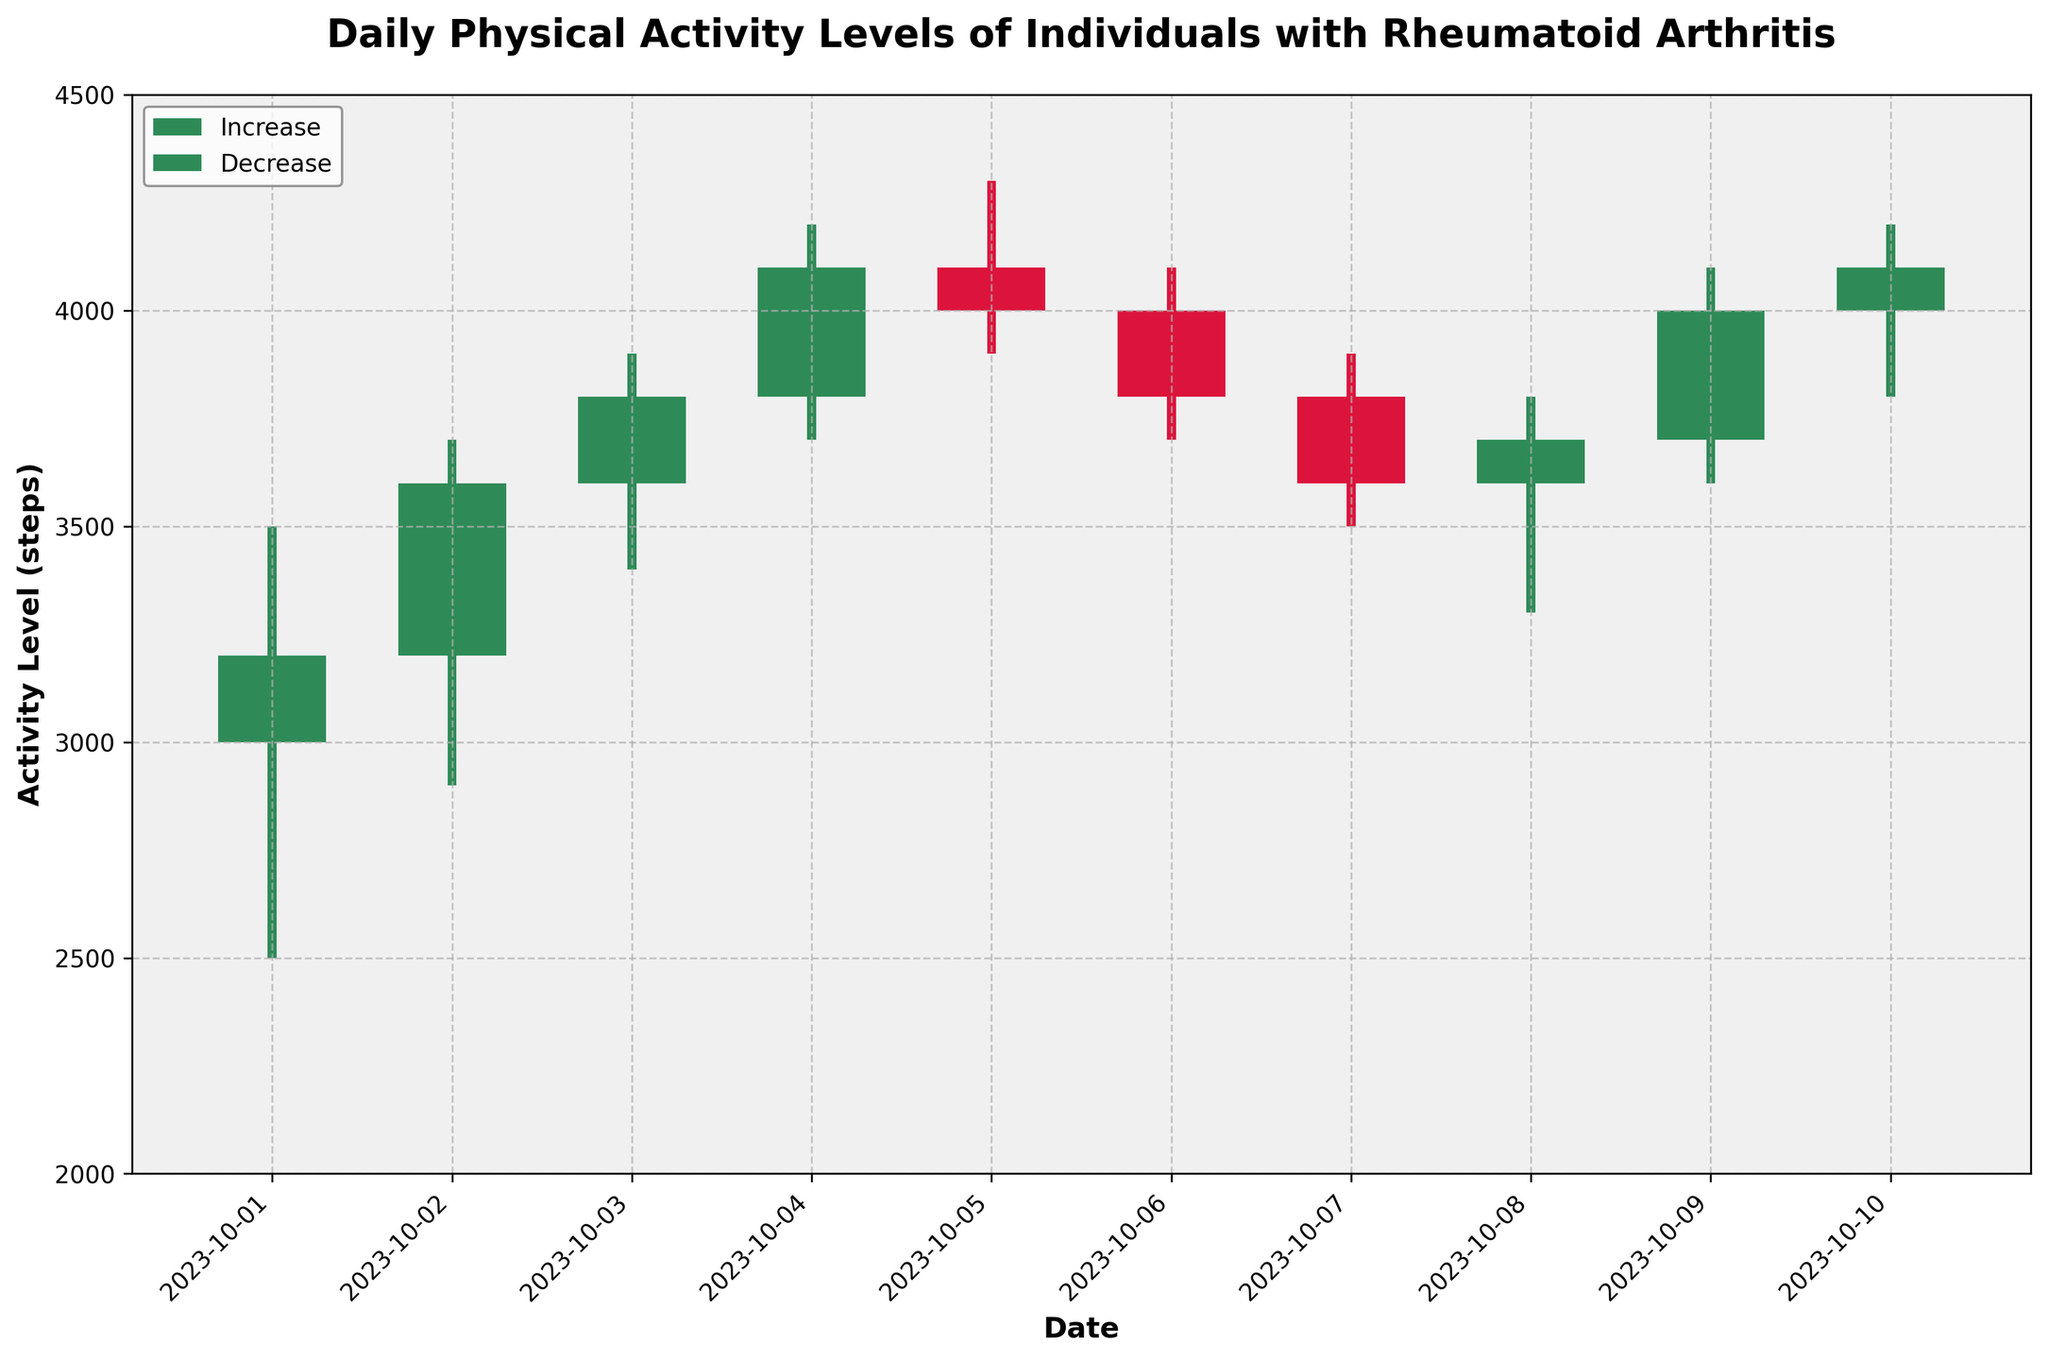What is the title of the figure? The title is located at the top of the figure and reads "Daily Physical Activity Levels of Individuals with Rheumatoid Arthritis".
Answer: Daily Physical Activity Levels of Individuals with Rheumatoid Arthritis How many days does the dataset cover? By looking at the x-axis which represents dates, the figure shows data points from October 1, 2023 to October 10, 2023.
Answer: 10 days On which date did the highest 'High' value occur? From the candlestick bars, the highest 'High' value can be found on October 4, 2023, reaching 4200 steps.
Answer: October 4, 2023 How many days had an increase in activity levels compared to the previous day? The days with green bars indicate an increase in activity levels (Close >= Open). These days are October 1, 2, 3, 4, 8, and 10, which counts as 6 days.
Answer: 6 days Which date had the largest drop in activity levels? The red bars indicate a decrease in activity levels (Close < Open). Among them, October 7, 2023 shows the largest decrease in activity levels from 3800 to 3600 steps, a difference of 200 steps.
Answer: October 7, 2023 What is the average 'Close' value over the 10 days? To find the average 'Close' value, sum the 'Close' values for all 10 days (3200 + 3600 + 3800 + 4100 + 4000 + 3800 + 3600 + 3700 + 4000 + 4100) which equals 37900, and then divide by 10.
Answer: 3790 Which day had the smallest range between 'High' and 'Low'? The range is calculated by subtracting 'Low' from 'High' for each day. The day with the smallest range is October 5, 2023: 4300 - 3900 = 400 steps.
Answer: October 5, 2023 How many times did the 'Close' value hit exactly 4100? By reviewing the candlestick plot and focusing on the 'Close' values, 4100 occurs on October 4, 2023 and October 10, 2023. This happens 2 times.
Answer: 2 times 